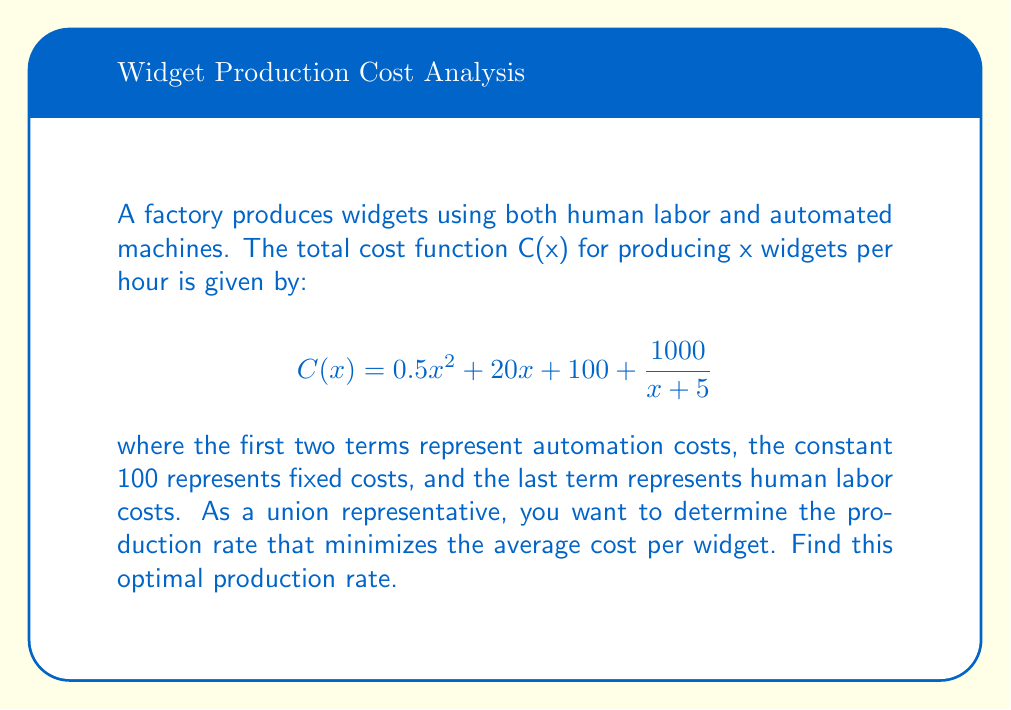What is the answer to this math problem? To find the optimal production rate that minimizes the average cost per widget, we need to follow these steps:

1) First, let's define the average cost function A(x):

   $$A(x) = \frac{C(x)}{x} = \frac{0.5x^2 + 20x + 100 + \frac{1000}{x+5}}{x}$$

2) To minimize A(x), we need to find where its derivative equals zero. Let's calculate A'(x):

   $$A'(x) = \frac{(x+5)(x^2 + 40x + 200) - (0.5x^3 + 20x^2 + 100x + 1000)}{x^2(x+5)}$$

3) Simplify the numerator:

   $$A'(x) = \frac{x^3 + 45x^2 + 400x + 1000 - (0.5x^3 + 20x^2 + 100x + 1000)}{x^2(x+5)}$$
   $$A'(x) = \frac{0.5x^3 + 25x^2 + 300x}{x^2(x+5)}$$

4) Set A'(x) = 0 and solve for x:

   $$\frac{0.5x^3 + 25x^2 + 300x}{x^2(x+5)} = 0$$

   $$0.5x^3 + 25x^2 + 300x = 0$$
   $$x(0.5x^2 + 25x + 300) = 0$$

5) Solve this equation. x = 0 is not a valid solution for our context. For the quadratic factor:

   $$0.5x^2 + 25x + 300 = 0$$
   $$x = \frac{-25 \pm \sqrt{25^2 - 4(0.5)(300)}}{2(0.5)}$$
   $$x \approx 20$$

6) Verify that this critical point indeed minimizes A(x) by checking the second derivative or examining the behavior of A(x) around x = 20.

Therefore, the optimal production rate is approximately 20 widgets per hour.
Answer: 20 widgets per hour 